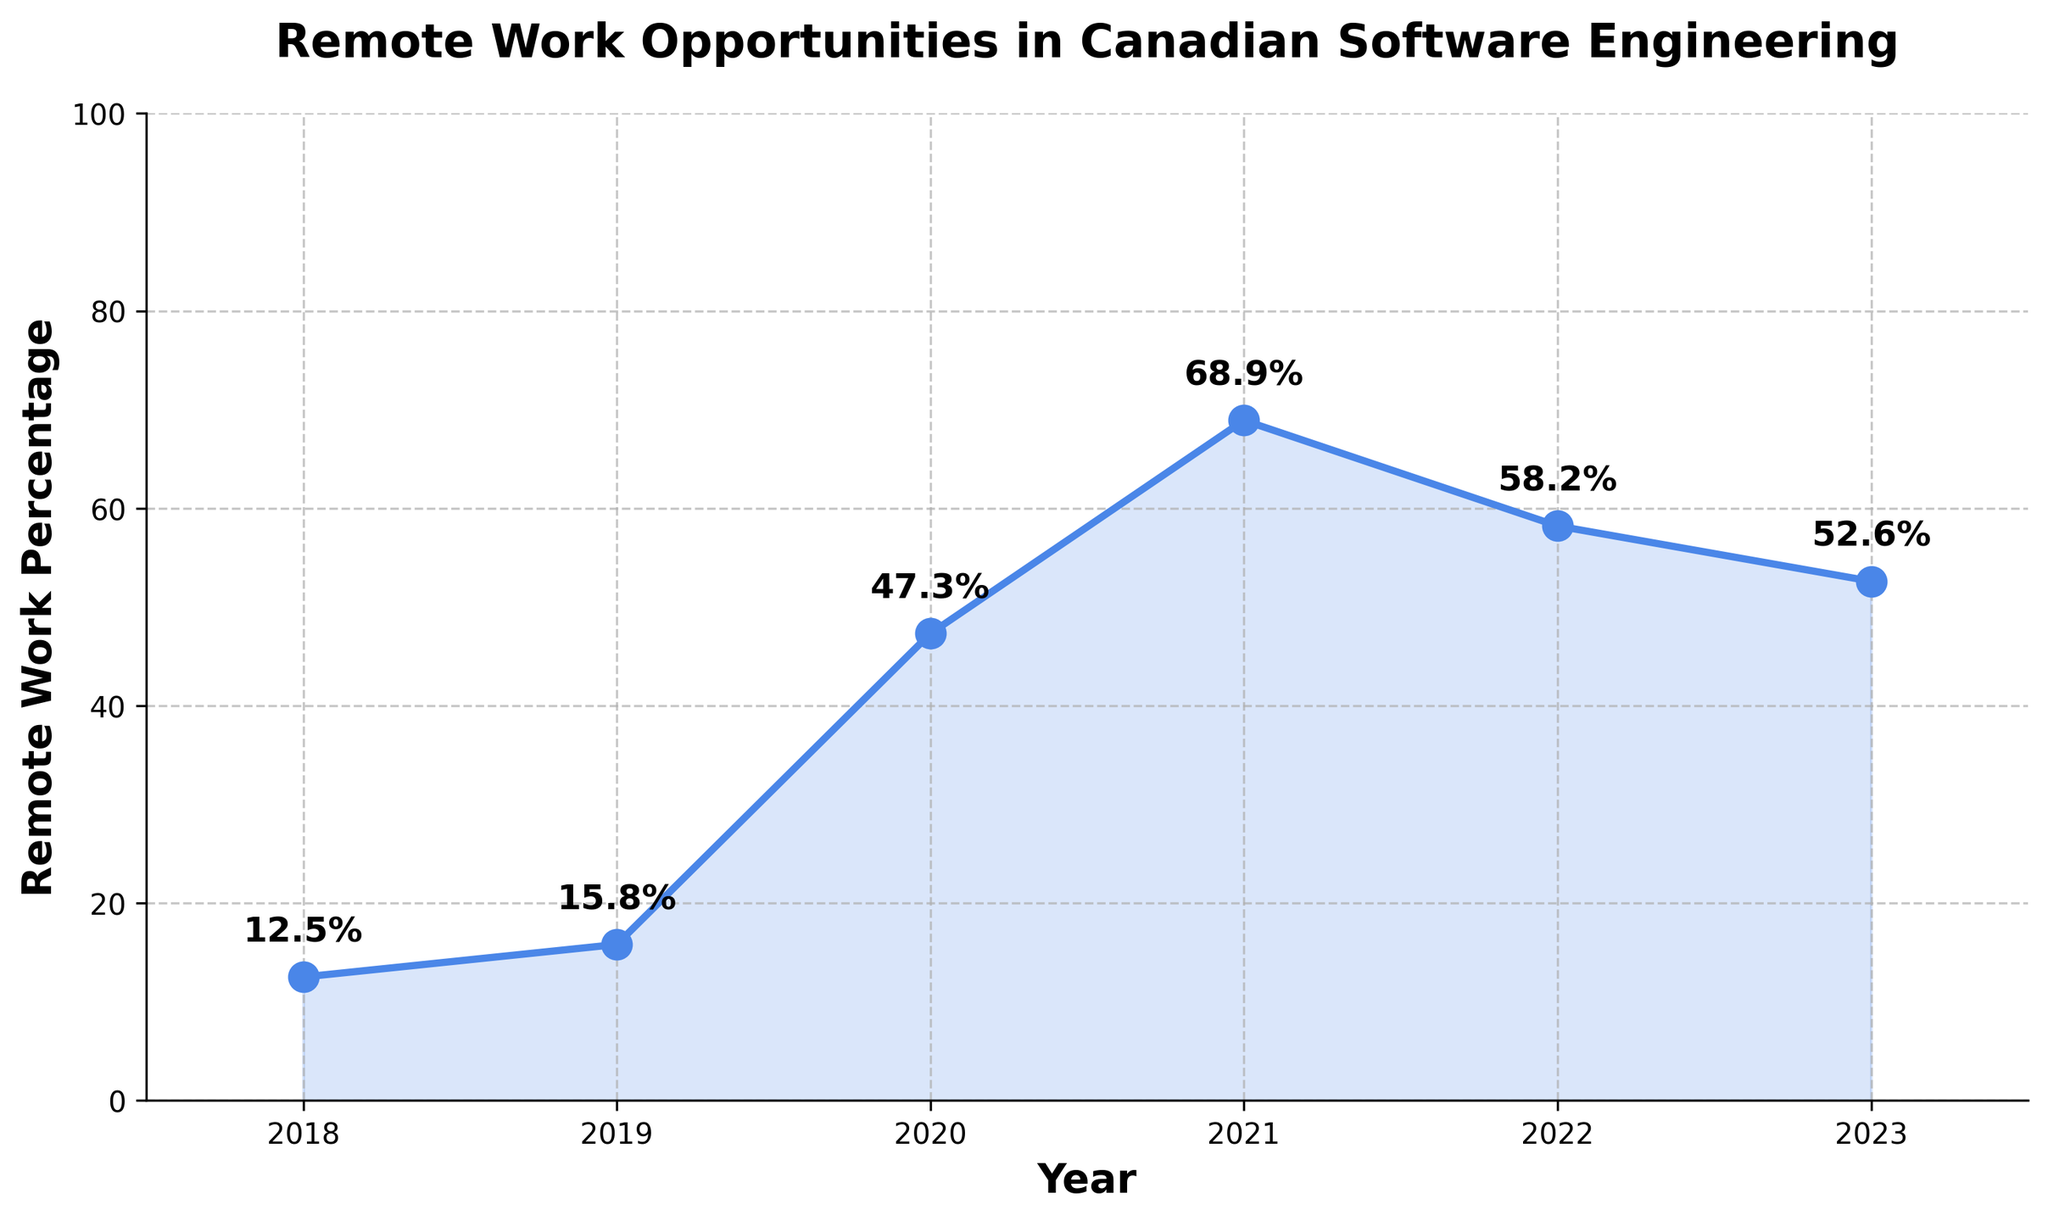How did the percentage of remote work opportunities change from 2018 to 2023? First, note the percentage of remote work opportunities in 2018, which is 12.5%, and in 2023, which is 52.6%. Subtract the earlier year's value from the later year's value: 52.6% - 12.5% = 40.1%.
Answer: Increased by 40.1% Which year saw the largest increase in the percentage of remote work opportunities? Compare the percentage increase year over year: 2018-2019 (15.8% - 12.5% = 3.3%), 2019-2020 (47.3% - 15.8% = 31.5%), 2020-2021 (68.9% - 47.3% = 21.6%), 2021-2022 (58.2% - 68.9% = -10.7%), and 2022-2023 (52.6% - 58.2% = -5.6%). The largest increase is from 2019 to 2020 with 31.5%.
Answer: 2020 What was the trend in remote work opportunities from 2021 to 2023? Note the percentages for 2021, 2022, and 2023: 68.9%, 58.2%, and 52.6%, respectively. Observe that each year's percentage is lower than the previous year's, indicating a decreasing trend.
Answer: Decreasing In which year did remote work opportunities peak? Look at the data points on the chart and identify the highest percentage value, which is in 2021 at 68.9%.
Answer: 2021 What was the average percentage of remote work opportunities from 2018 to 2023? First, sum the percentages: 12.5 + 15.8 + 47.3 + 68.9 + 58.2 + 52.6 = 255.3. Then, divide by the number of years, which is 6: 255.3 / 6 ≈ 42.55%.
Answer: 42.55% By how much did the percentage of remote work opportunities decrease from 2021 to 2023? First, note the value in 2021 (68.9%) and 2023 (52.6%). Subtract the 2023 value from the 2021 value: 68.9% - 52.6% = 16.3%.
Answer: 16.3% How does the percentage of remote work opportunities in 2019 compare to that in 2018? Note the percentages for 2018 (12.5%) and 2019 (15.8%). Since 15.8% > 12.5%, 2019 has a higher percentage.
Answer: Higher What is the average percentage of remote work opportunities for the years 2020 and 2021? Sum the percentages for 2020 (47.3%) and 2021 (68.9%) and divide by 2: (47.3 + 68.9) / 2 = 116.2 / 2 = 58.1%.
Answer: 58.1% Between which consecutive years was there a decrease in the percentage of remote work opportunities? Check the differences: 2018-2019 (+3.3%), 2019-2020 (+31.5%), 2020-2021 (+21.6%), 2021-2022 (-10.7%), and 2022-2023 (-5.6%). There were decreases between 2021-2022 and 2022-2023.
Answer: 2021-2022, 2022-2023 What was the percentage point increase in remote work opportunities from 2019 to 2020? Note the percentages for 2019 (15.8%) and 2020 (47.3%). Subtract the 2019 value from the 2020 value: 47.3% - 15.8% = 31.5%.
Answer: 31.5% 